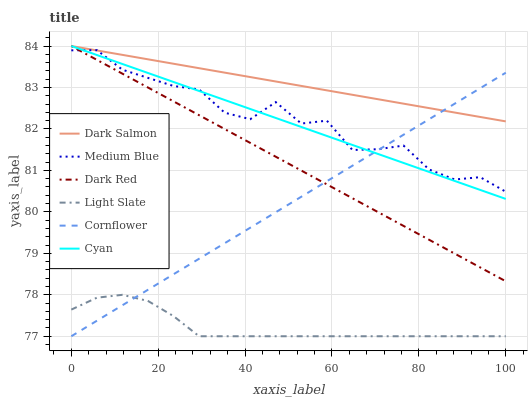Does Light Slate have the minimum area under the curve?
Answer yes or no. Yes. Does Dark Salmon have the maximum area under the curve?
Answer yes or no. Yes. Does Dark Red have the minimum area under the curve?
Answer yes or no. No. Does Dark Red have the maximum area under the curve?
Answer yes or no. No. Is Cornflower the smoothest?
Answer yes or no. Yes. Is Medium Blue the roughest?
Answer yes or no. Yes. Is Light Slate the smoothest?
Answer yes or no. No. Is Light Slate the roughest?
Answer yes or no. No. Does Cornflower have the lowest value?
Answer yes or no. Yes. Does Dark Red have the lowest value?
Answer yes or no. No. Does Cyan have the highest value?
Answer yes or no. Yes. Does Light Slate have the highest value?
Answer yes or no. No. Is Light Slate less than Dark Salmon?
Answer yes or no. Yes. Is Medium Blue greater than Light Slate?
Answer yes or no. Yes. Does Dark Salmon intersect Cornflower?
Answer yes or no. Yes. Is Dark Salmon less than Cornflower?
Answer yes or no. No. Is Dark Salmon greater than Cornflower?
Answer yes or no. No. Does Light Slate intersect Dark Salmon?
Answer yes or no. No. 